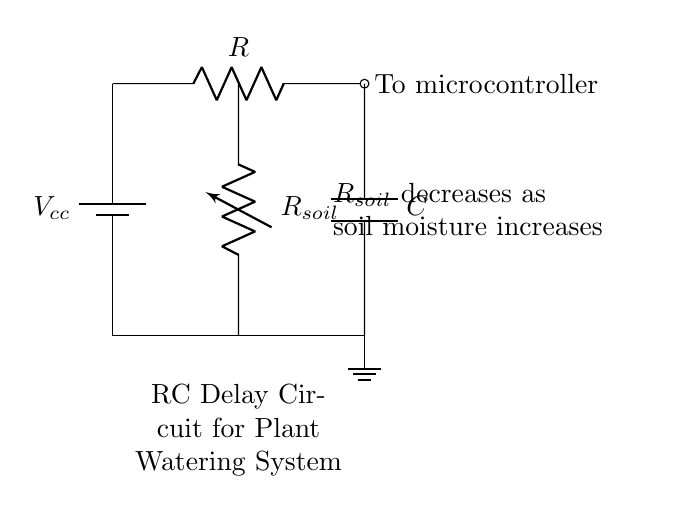What is the purpose of the capacitor in this circuit? The capacitor in an RC delay circuit stores electrical energy and releases it slowly, which helps create a delay in the response of the circuit.
Answer: delay What component is represented by the variable resistor? The variable resistor represents the soil moisture sensor, which changes its resistance based on the moisture level in the soil.
Answer: soil moisture sensor What happens to the resistance of the soil sensor as moisture increases? As moisture increases, the resistance of the soil moisture sensor decreases, allowing more current to flow through the circuit.
Answer: decreases What is the connection type between the capacitor and the ground? The capacitor is connected in parallel to the ground via the resistor and soil moisture sensor, creating a path for current when the circuit operates.
Answer: parallel What role does the resistor play in the timing characteristics of the circuit? The resistor controls the charge and discharge rate of the capacitor, influencing how long the delay lasts before the circuit activates the watering system.
Answer: timing What is the voltage source supplying this circuit? The voltage source for this circuit is indicated as Vcc, which provides the necessary potential difference for circuit operation.
Answer: Vcc How many main components are visible in the circuit diagram? The main components visible in the circuit diagram include a battery, resistor, capacitor, and variable resistor (soil moisture sensor), totaling four components.
Answer: four 